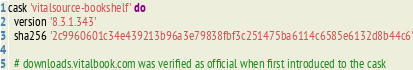<code> <loc_0><loc_0><loc_500><loc_500><_Ruby_>cask 'vitalsource-bookshelf' do
  version '8.3.1.343'
  sha256 '2c9960601c34e439213b96a3e79838fbf3c251475ba6114c6585e6132d8b44c6'

  # downloads.vitalbook.com was verified as official when first introduced to the cask</code> 